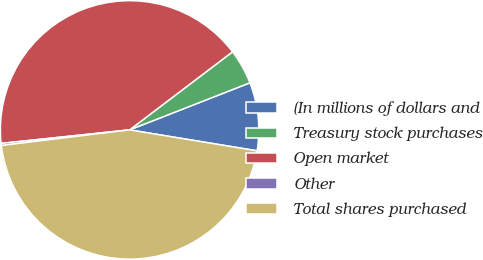Convert chart. <chart><loc_0><loc_0><loc_500><loc_500><pie_chart><fcel>(In millions of dollars and<fcel>Treasury stock purchases<fcel>Open market<fcel>Other<fcel>Total shares purchased<nl><fcel>8.53%<fcel>4.39%<fcel>41.34%<fcel>0.26%<fcel>45.48%<nl></chart> 